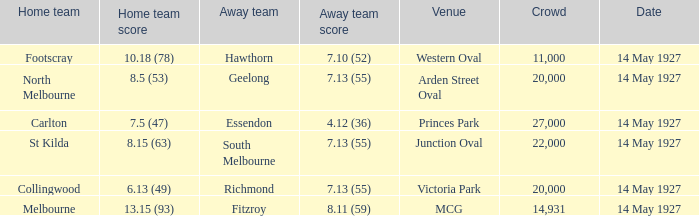Which venue hosted a home team with a score of 13.15 (93)? MCG. 